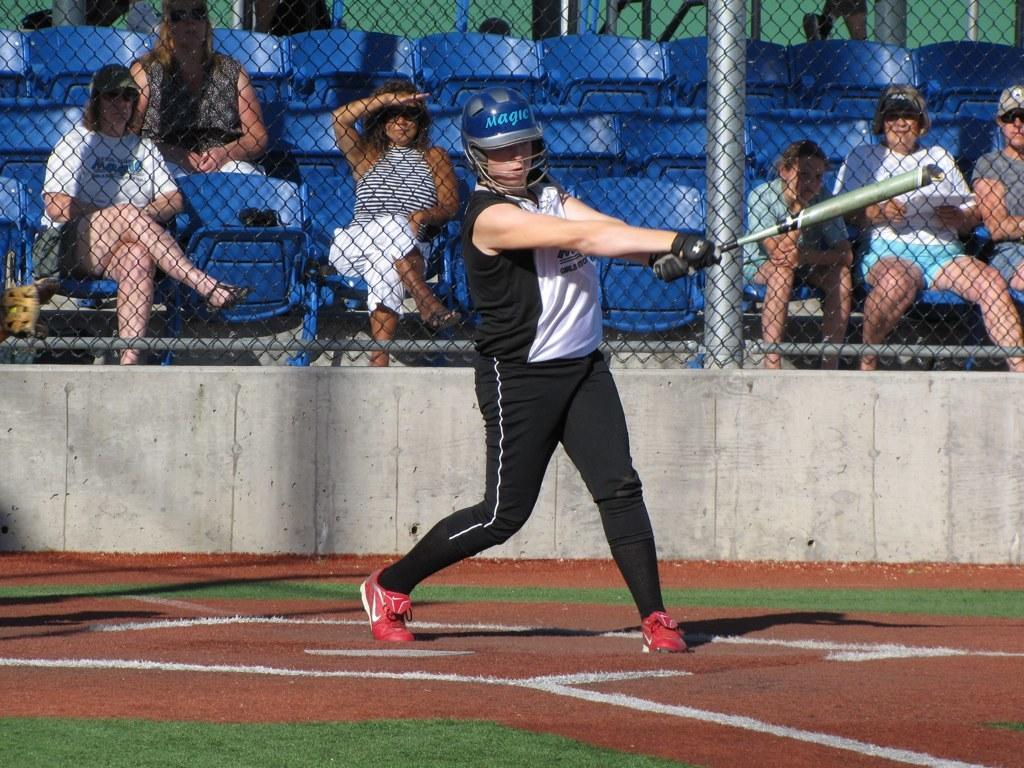What is the main subject of the image? There is a person standing in the center of the image. What is the person holding in the image? The person is holding a bat. What can be seen in the background of the image? There are chairs, people sitting in the chairs, and a fence in the background of the image. How many rabbits can be seen playing with a light bulb in the image? There are no rabbits or light bulbs present in the image. What type of ornament is hanging from the fence in the image? There is no ornament hanging from the fence in the image; only the fence can be seen in the background. 